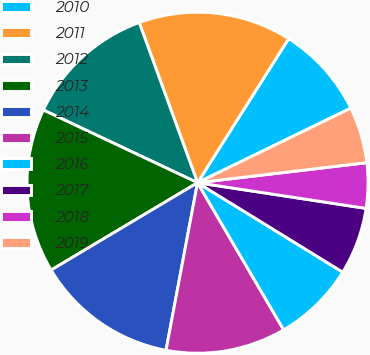Convert chart. <chart><loc_0><loc_0><loc_500><loc_500><pie_chart><fcel>2010<fcel>2011<fcel>2012<fcel>2013<fcel>2014<fcel>2015<fcel>2016<fcel>2017<fcel>2018<fcel>2019<nl><fcel>8.82%<fcel>14.53%<fcel>12.43%<fcel>15.57%<fcel>13.48%<fcel>11.39%<fcel>7.78%<fcel>6.38%<fcel>4.28%<fcel>5.33%<nl></chart> 